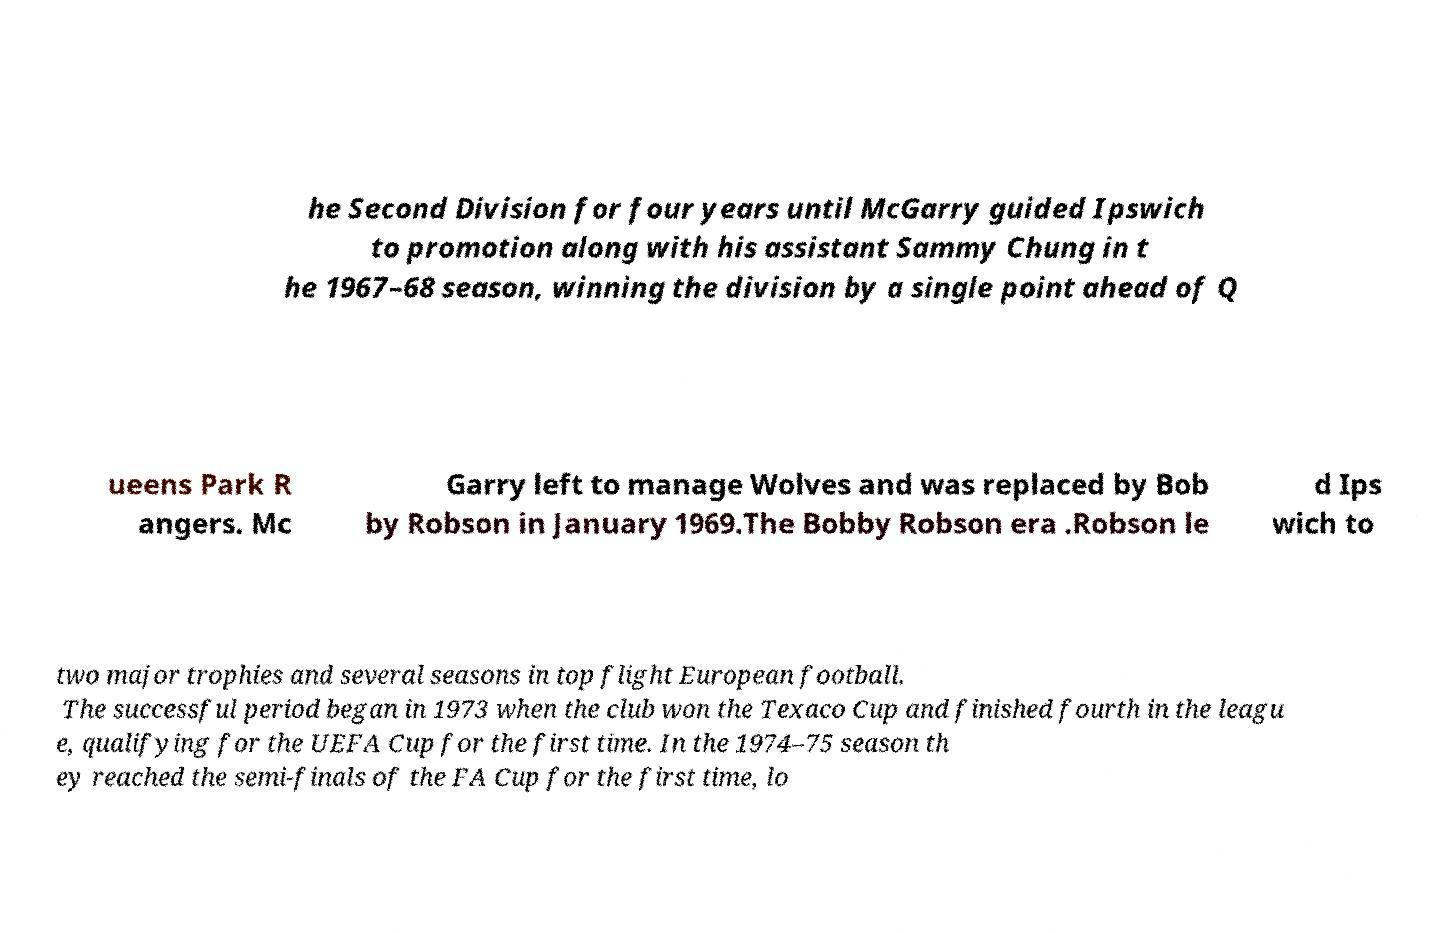There's text embedded in this image that I need extracted. Can you transcribe it verbatim? he Second Division for four years until McGarry guided Ipswich to promotion along with his assistant Sammy Chung in t he 1967–68 season, winning the division by a single point ahead of Q ueens Park R angers. Mc Garry left to manage Wolves and was replaced by Bob by Robson in January 1969.The Bobby Robson era .Robson le d Ips wich to two major trophies and several seasons in top flight European football. The successful period began in 1973 when the club won the Texaco Cup and finished fourth in the leagu e, qualifying for the UEFA Cup for the first time. In the 1974–75 season th ey reached the semi-finals of the FA Cup for the first time, lo 